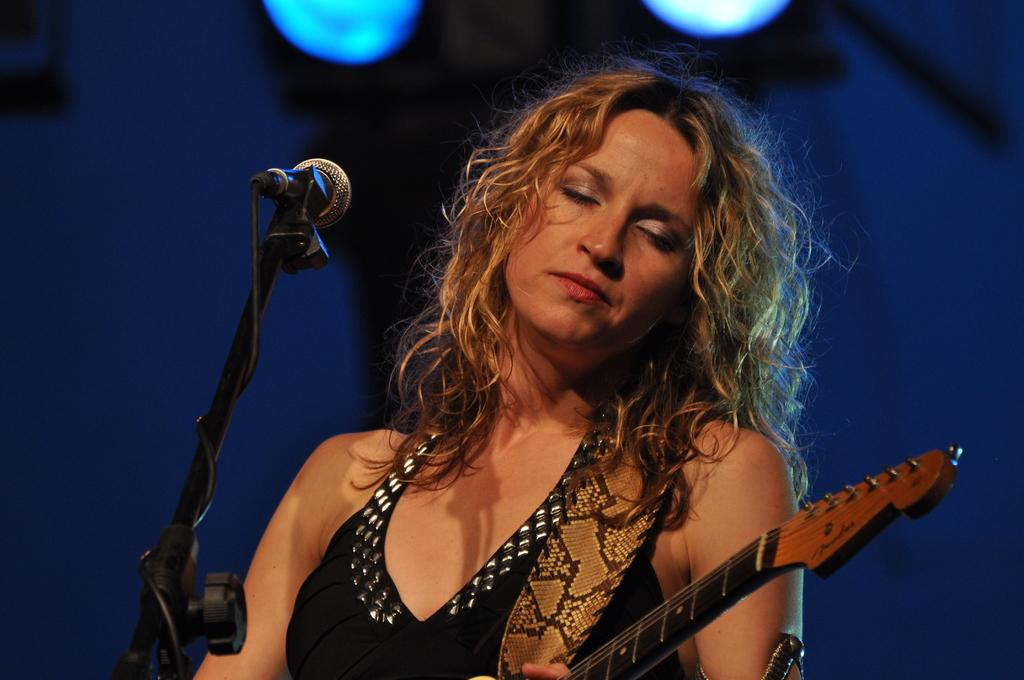Who is the main subject in the image? There is a woman in the image. What is the woman holding in the image? The woman is holding a guitar. What object is in front of the woman? There is a microphone (mic) in front of the woman. What type of treatment is the woman seeking from the beggar in the image? There is no beggar present in the image, so the woman is not seeking any treatment from a beggar. 